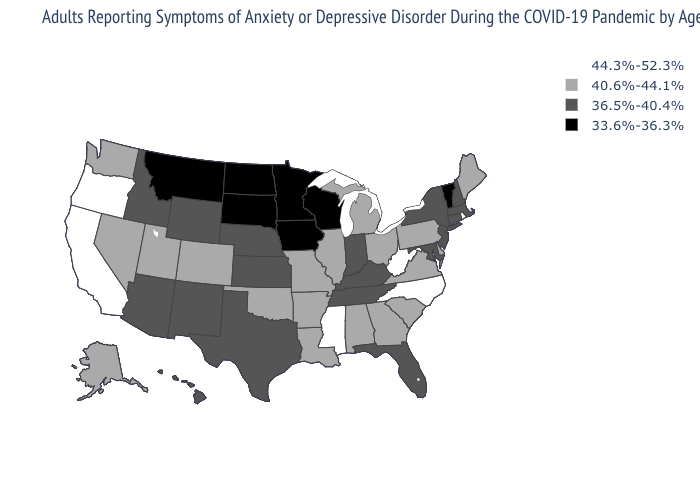Which states hav the highest value in the West?
Be succinct. California, Oregon. Which states have the highest value in the USA?
Keep it brief. California, Mississippi, North Carolina, Oregon, Rhode Island, West Virginia. Does Louisiana have a higher value than Alaska?
Write a very short answer. No. Does West Virginia have the highest value in the USA?
Concise answer only. Yes. Which states hav the highest value in the West?
Concise answer only. California, Oregon. What is the value of New York?
Give a very brief answer. 36.5%-40.4%. Name the states that have a value in the range 44.3%-52.3%?
Quick response, please. California, Mississippi, North Carolina, Oregon, Rhode Island, West Virginia. Name the states that have a value in the range 33.6%-36.3%?
Concise answer only. Iowa, Minnesota, Montana, North Dakota, South Dakota, Vermont, Wisconsin. Does Hawaii have a higher value than Minnesota?
Write a very short answer. Yes. Among the states that border North Dakota , which have the lowest value?
Write a very short answer. Minnesota, Montana, South Dakota. What is the lowest value in states that border Alabama?
Write a very short answer. 36.5%-40.4%. Does Vermont have the lowest value in the Northeast?
Be succinct. Yes. Name the states that have a value in the range 36.5%-40.4%?
Quick response, please. Arizona, Connecticut, Florida, Hawaii, Idaho, Indiana, Kansas, Kentucky, Maryland, Massachusetts, Nebraska, New Hampshire, New Jersey, New Mexico, New York, Tennessee, Texas, Wyoming. Name the states that have a value in the range 36.5%-40.4%?
Concise answer only. Arizona, Connecticut, Florida, Hawaii, Idaho, Indiana, Kansas, Kentucky, Maryland, Massachusetts, Nebraska, New Hampshire, New Jersey, New Mexico, New York, Tennessee, Texas, Wyoming. What is the value of West Virginia?
Quick response, please. 44.3%-52.3%. 